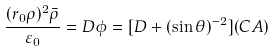<formula> <loc_0><loc_0><loc_500><loc_500>\frac { ( r _ { 0 } \rho ) ^ { 2 } \bar { \rho } } { \varepsilon _ { 0 } } = D \phi = [ D + ( \sin \theta ) ^ { - 2 } ] ( C A )</formula> 